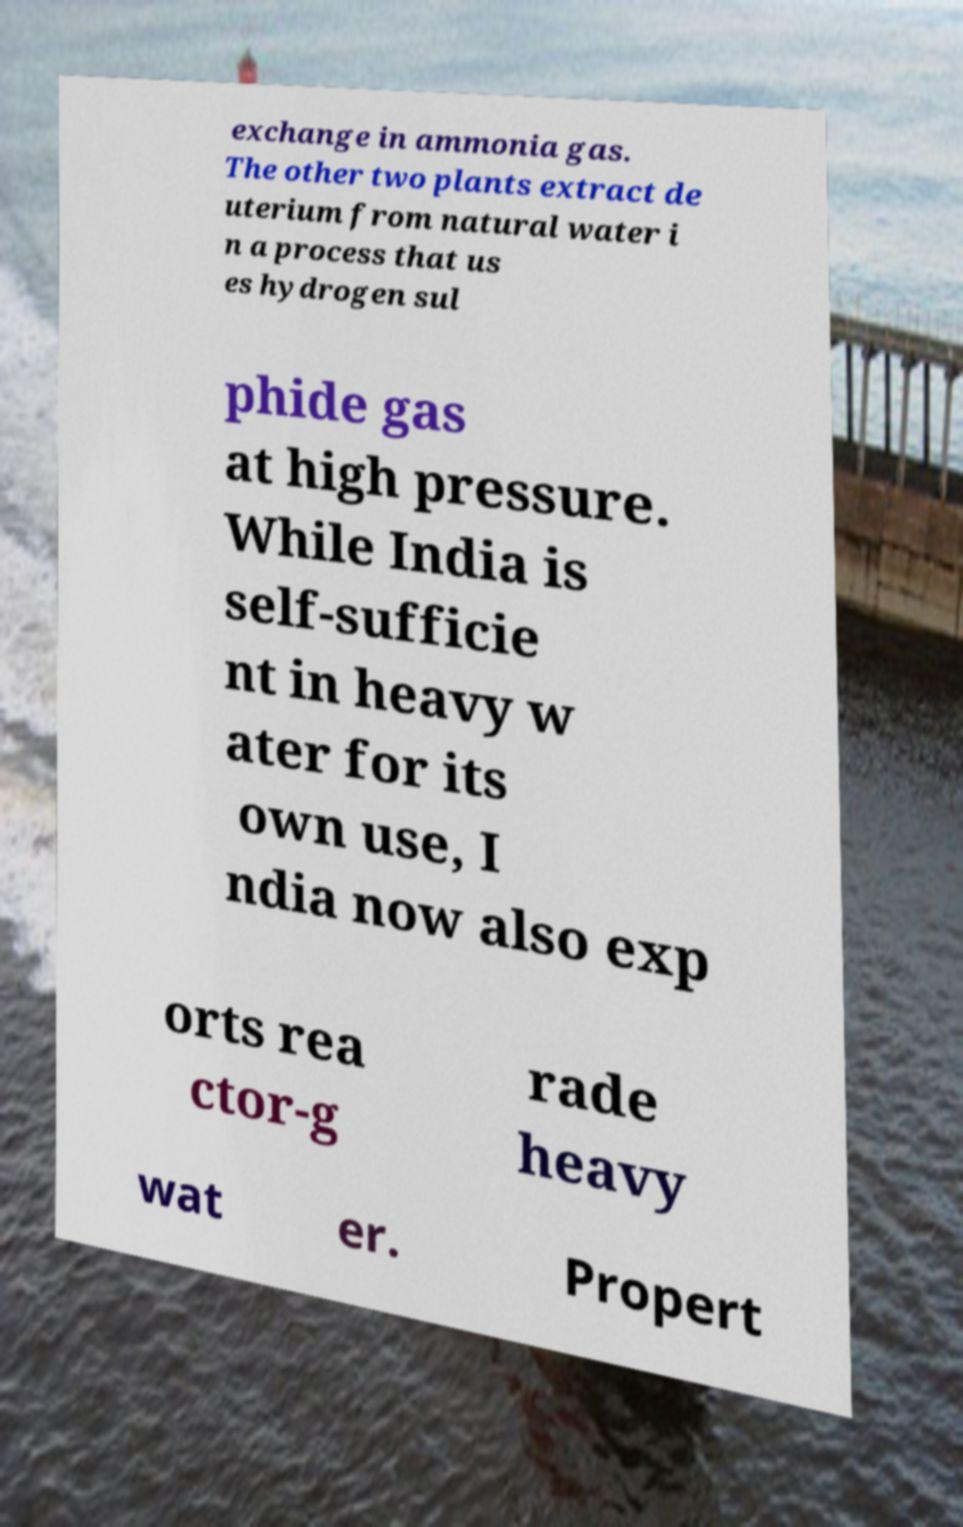What messages or text are displayed in this image? I need them in a readable, typed format. exchange in ammonia gas. The other two plants extract de uterium from natural water i n a process that us es hydrogen sul phide gas at high pressure. While India is self-sufficie nt in heavy w ater for its own use, I ndia now also exp orts rea ctor-g rade heavy wat er. Propert 